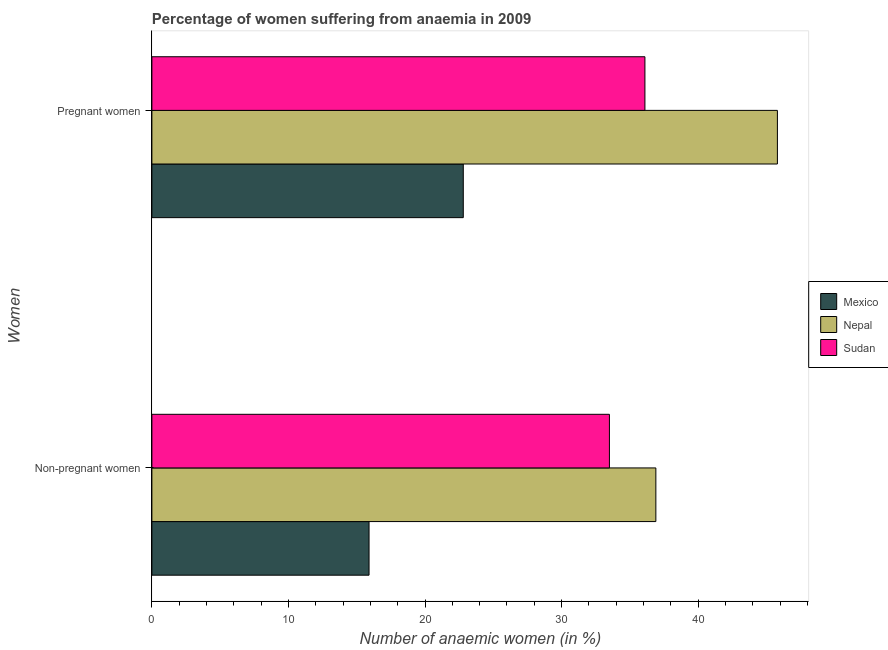How many different coloured bars are there?
Give a very brief answer. 3. Are the number of bars per tick equal to the number of legend labels?
Give a very brief answer. Yes. How many bars are there on the 2nd tick from the top?
Your response must be concise. 3. How many bars are there on the 1st tick from the bottom?
Offer a terse response. 3. What is the label of the 2nd group of bars from the top?
Your answer should be very brief. Non-pregnant women. What is the percentage of pregnant anaemic women in Mexico?
Your answer should be compact. 22.8. Across all countries, what is the maximum percentage of non-pregnant anaemic women?
Your answer should be compact. 36.9. Across all countries, what is the minimum percentage of pregnant anaemic women?
Your answer should be compact. 22.8. In which country was the percentage of pregnant anaemic women maximum?
Your response must be concise. Nepal. In which country was the percentage of non-pregnant anaemic women minimum?
Keep it short and to the point. Mexico. What is the total percentage of pregnant anaemic women in the graph?
Make the answer very short. 104.7. What is the difference between the percentage of non-pregnant anaemic women in Nepal and the percentage of pregnant anaemic women in Sudan?
Ensure brevity in your answer.  0.8. What is the average percentage of non-pregnant anaemic women per country?
Keep it short and to the point. 28.77. What is the ratio of the percentage of non-pregnant anaemic women in Mexico to that in Nepal?
Keep it short and to the point. 0.43. In how many countries, is the percentage of non-pregnant anaemic women greater than the average percentage of non-pregnant anaemic women taken over all countries?
Your answer should be compact. 2. What does the 1st bar from the top in Pregnant women represents?
Provide a succinct answer. Sudan. What does the 2nd bar from the bottom in Pregnant women represents?
Give a very brief answer. Nepal. Are all the bars in the graph horizontal?
Offer a very short reply. Yes. How many countries are there in the graph?
Provide a short and direct response. 3. Does the graph contain any zero values?
Your answer should be very brief. No. Does the graph contain grids?
Your answer should be very brief. No. Where does the legend appear in the graph?
Your answer should be compact. Center right. How many legend labels are there?
Give a very brief answer. 3. What is the title of the graph?
Your answer should be compact. Percentage of women suffering from anaemia in 2009. What is the label or title of the X-axis?
Offer a very short reply. Number of anaemic women (in %). What is the label or title of the Y-axis?
Make the answer very short. Women. What is the Number of anaemic women (in %) in Mexico in Non-pregnant women?
Provide a short and direct response. 15.9. What is the Number of anaemic women (in %) of Nepal in Non-pregnant women?
Keep it short and to the point. 36.9. What is the Number of anaemic women (in %) of Sudan in Non-pregnant women?
Your answer should be very brief. 33.5. What is the Number of anaemic women (in %) in Mexico in Pregnant women?
Give a very brief answer. 22.8. What is the Number of anaemic women (in %) of Nepal in Pregnant women?
Your answer should be compact. 45.8. What is the Number of anaemic women (in %) of Sudan in Pregnant women?
Offer a very short reply. 36.1. Across all Women, what is the maximum Number of anaemic women (in %) in Mexico?
Ensure brevity in your answer.  22.8. Across all Women, what is the maximum Number of anaemic women (in %) of Nepal?
Provide a succinct answer. 45.8. Across all Women, what is the maximum Number of anaemic women (in %) in Sudan?
Your answer should be very brief. 36.1. Across all Women, what is the minimum Number of anaemic women (in %) in Mexico?
Provide a succinct answer. 15.9. Across all Women, what is the minimum Number of anaemic women (in %) of Nepal?
Ensure brevity in your answer.  36.9. Across all Women, what is the minimum Number of anaemic women (in %) of Sudan?
Offer a terse response. 33.5. What is the total Number of anaemic women (in %) in Mexico in the graph?
Your response must be concise. 38.7. What is the total Number of anaemic women (in %) of Nepal in the graph?
Give a very brief answer. 82.7. What is the total Number of anaemic women (in %) in Sudan in the graph?
Give a very brief answer. 69.6. What is the difference between the Number of anaemic women (in %) in Mexico in Non-pregnant women and that in Pregnant women?
Provide a succinct answer. -6.9. What is the difference between the Number of anaemic women (in %) of Nepal in Non-pregnant women and that in Pregnant women?
Your answer should be very brief. -8.9. What is the difference between the Number of anaemic women (in %) of Sudan in Non-pregnant women and that in Pregnant women?
Your answer should be very brief. -2.6. What is the difference between the Number of anaemic women (in %) of Mexico in Non-pregnant women and the Number of anaemic women (in %) of Nepal in Pregnant women?
Ensure brevity in your answer.  -29.9. What is the difference between the Number of anaemic women (in %) in Mexico in Non-pregnant women and the Number of anaemic women (in %) in Sudan in Pregnant women?
Offer a terse response. -20.2. What is the difference between the Number of anaemic women (in %) of Nepal in Non-pregnant women and the Number of anaemic women (in %) of Sudan in Pregnant women?
Give a very brief answer. 0.8. What is the average Number of anaemic women (in %) of Mexico per Women?
Provide a succinct answer. 19.35. What is the average Number of anaemic women (in %) of Nepal per Women?
Offer a terse response. 41.35. What is the average Number of anaemic women (in %) of Sudan per Women?
Provide a short and direct response. 34.8. What is the difference between the Number of anaemic women (in %) in Mexico and Number of anaemic women (in %) in Nepal in Non-pregnant women?
Your response must be concise. -21. What is the difference between the Number of anaemic women (in %) of Mexico and Number of anaemic women (in %) of Sudan in Non-pregnant women?
Make the answer very short. -17.6. What is the difference between the Number of anaemic women (in %) of Nepal and Number of anaemic women (in %) of Sudan in Non-pregnant women?
Offer a very short reply. 3.4. What is the ratio of the Number of anaemic women (in %) of Mexico in Non-pregnant women to that in Pregnant women?
Provide a short and direct response. 0.7. What is the ratio of the Number of anaemic women (in %) of Nepal in Non-pregnant women to that in Pregnant women?
Your response must be concise. 0.81. What is the ratio of the Number of anaemic women (in %) in Sudan in Non-pregnant women to that in Pregnant women?
Keep it short and to the point. 0.93. What is the difference between the highest and the second highest Number of anaemic women (in %) in Nepal?
Offer a very short reply. 8.9. What is the difference between the highest and the second highest Number of anaemic women (in %) in Sudan?
Your answer should be very brief. 2.6. What is the difference between the highest and the lowest Number of anaemic women (in %) in Mexico?
Your answer should be very brief. 6.9. What is the difference between the highest and the lowest Number of anaemic women (in %) in Sudan?
Keep it short and to the point. 2.6. 